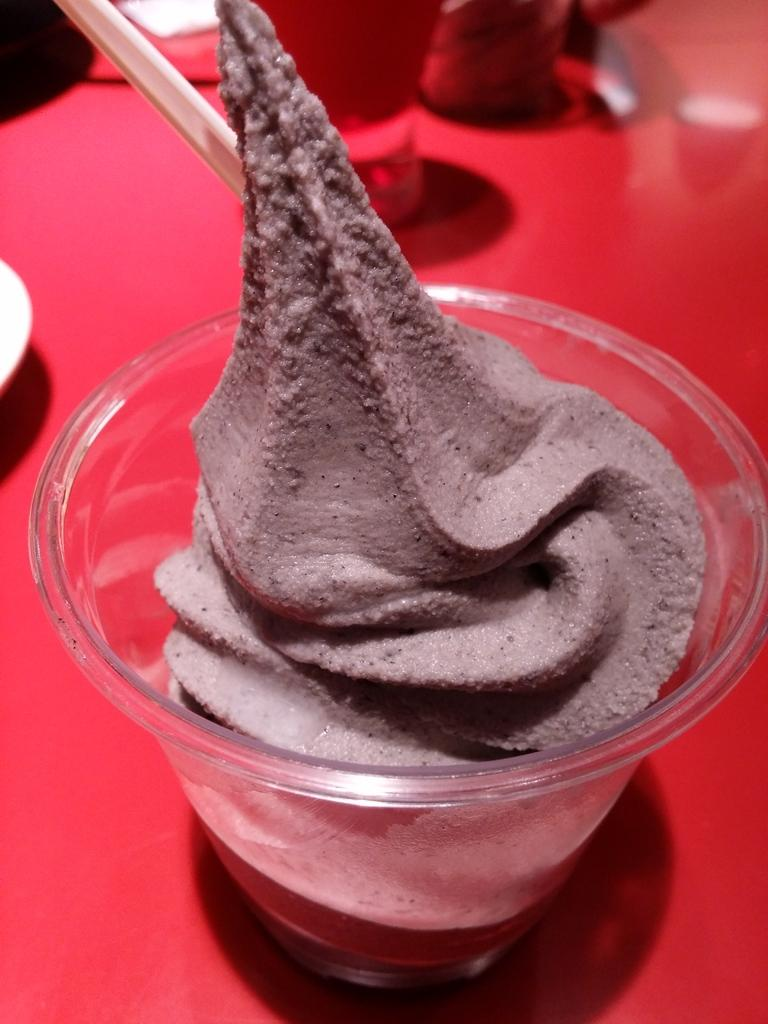What type of furniture is present in the image? There is a table in the image. What is in the glass that is on the table? There is cream in the glass on the table. What utensil is used with the glass? There is a spoon in the glass. What color is the object on the table? There is a red color object on the table. What other items can be seen on the table? There are additional objects on the table. Where is the fireman standing in the image? There is no fireman present in the image. What type of wire is connected to the roof in the image? There is no wire or roof present in the image. 